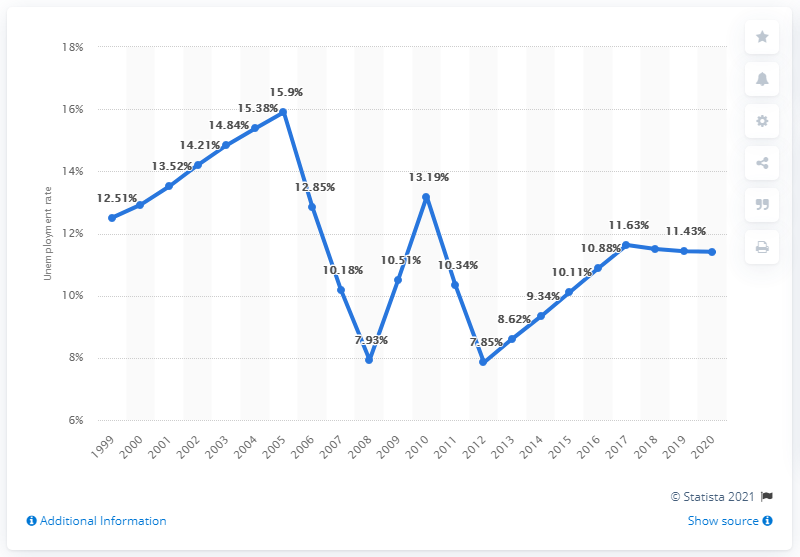Specify some key components in this picture. In 2020, the unemployment rate in Zambia was 11.41%. 